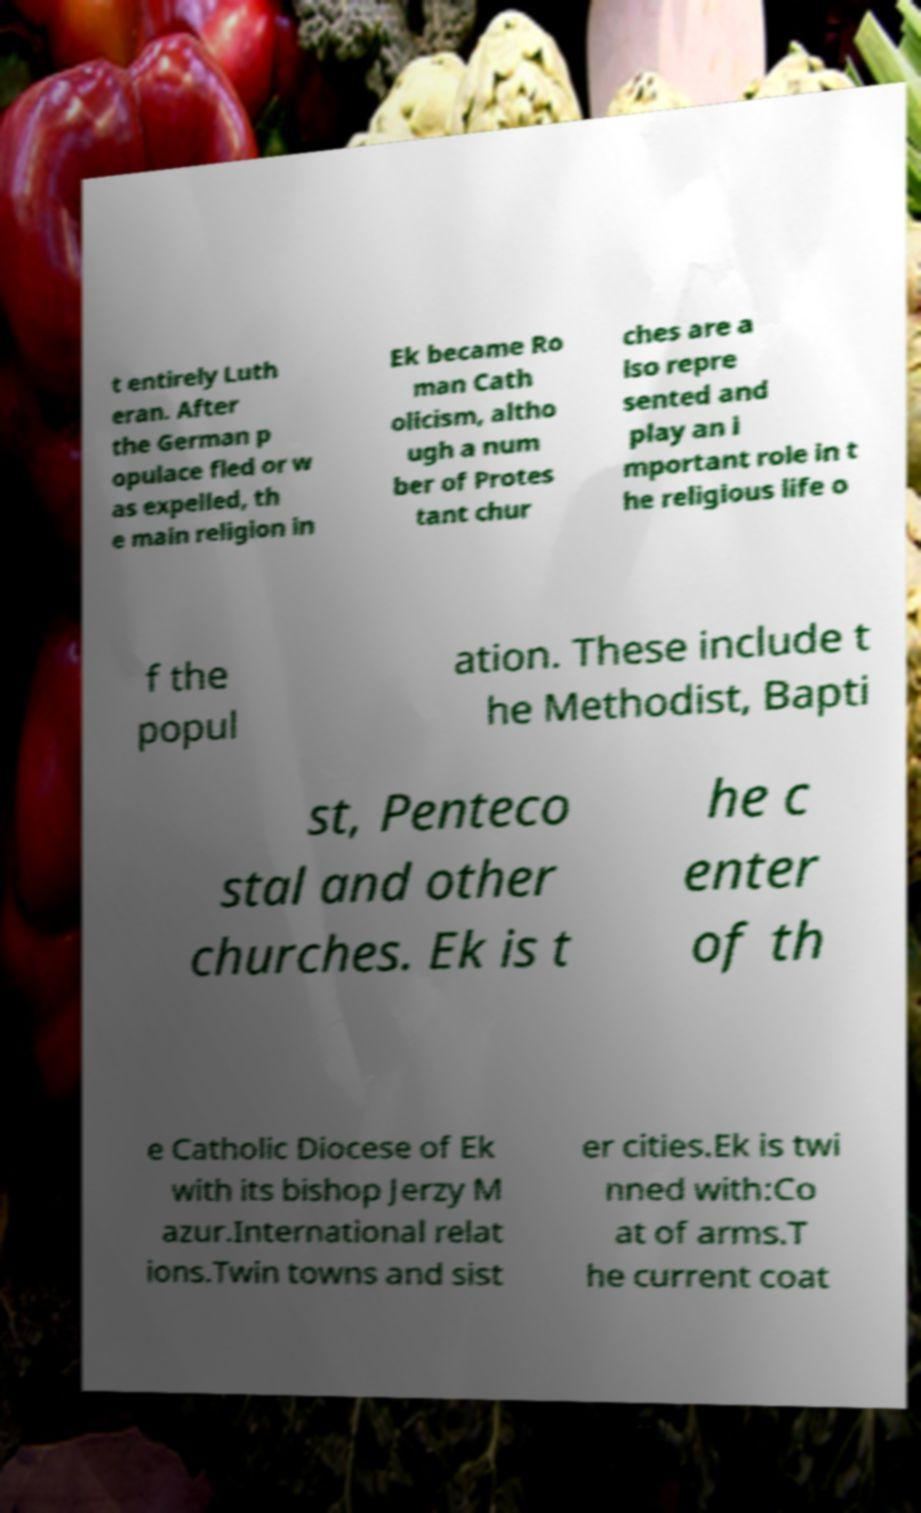For documentation purposes, I need the text within this image transcribed. Could you provide that? t entirely Luth eran. After the German p opulace fled or w as expelled, th e main religion in Ek became Ro man Cath olicism, altho ugh a num ber of Protes tant chur ches are a lso repre sented and play an i mportant role in t he religious life o f the popul ation. These include t he Methodist, Bapti st, Penteco stal and other churches. Ek is t he c enter of th e Catholic Diocese of Ek with its bishop Jerzy M azur.International relat ions.Twin towns and sist er cities.Ek is twi nned with:Co at of arms.T he current coat 